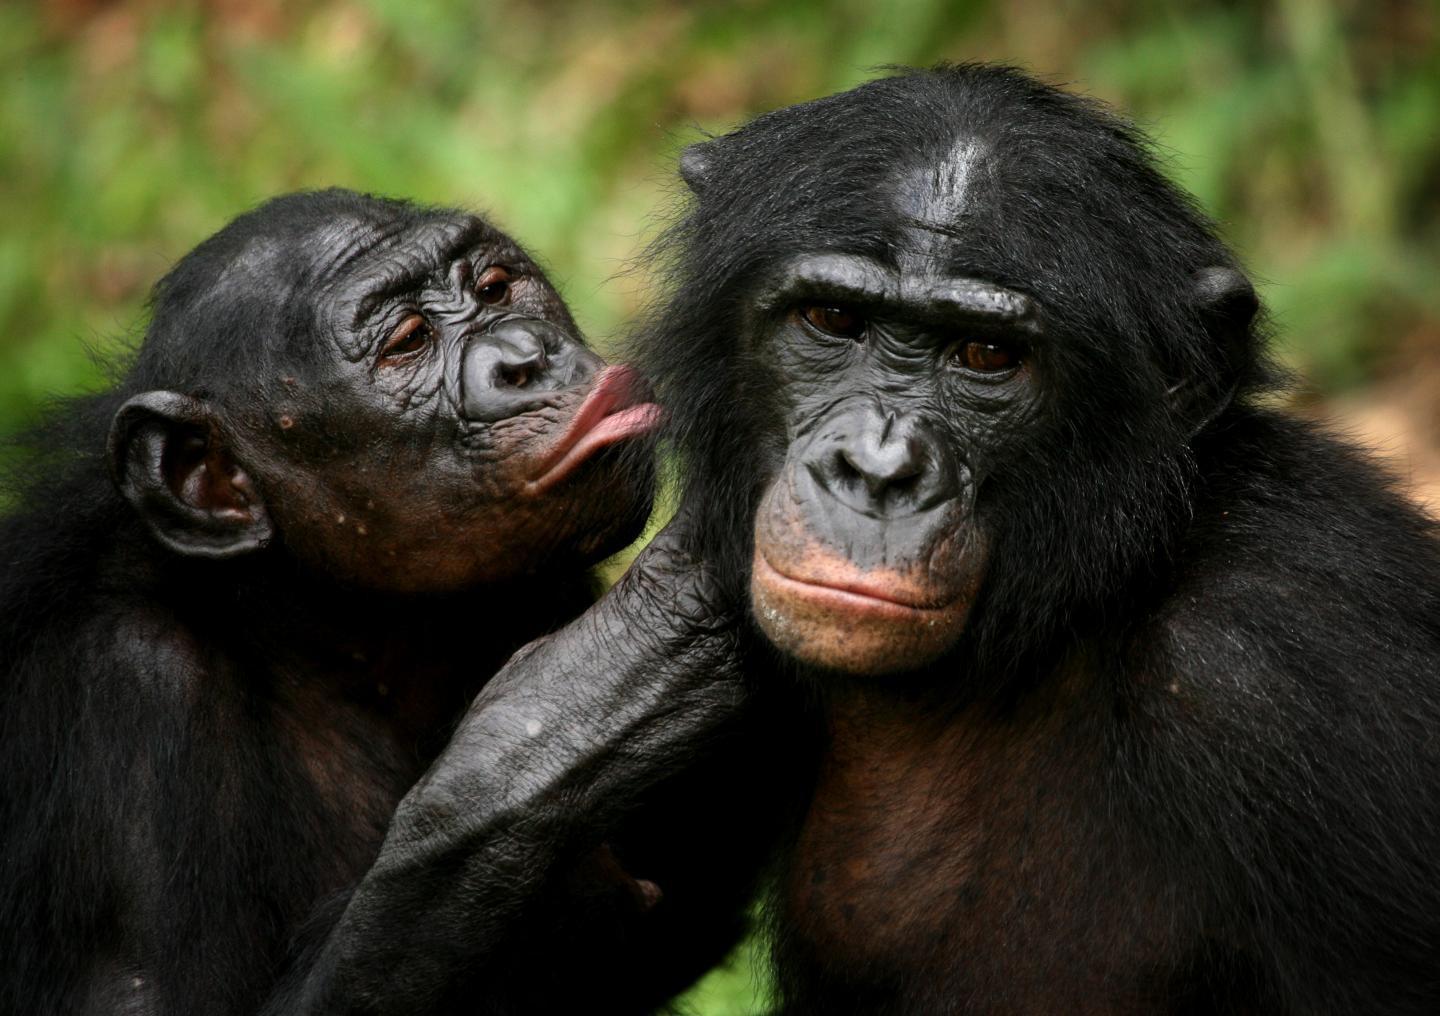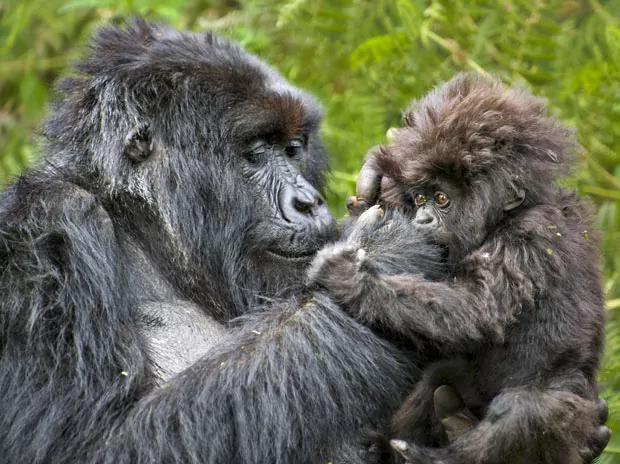The first image is the image on the left, the second image is the image on the right. Analyze the images presented: Is the assertion "An adult gorilla is holding a baby gorilla in the right image." valid? Answer yes or no. Yes. The first image is the image on the left, the second image is the image on the right. Analyze the images presented: Is the assertion "An image contains exactly two gorillas, whose faces are only a few inches apart." valid? Answer yes or no. Yes. 